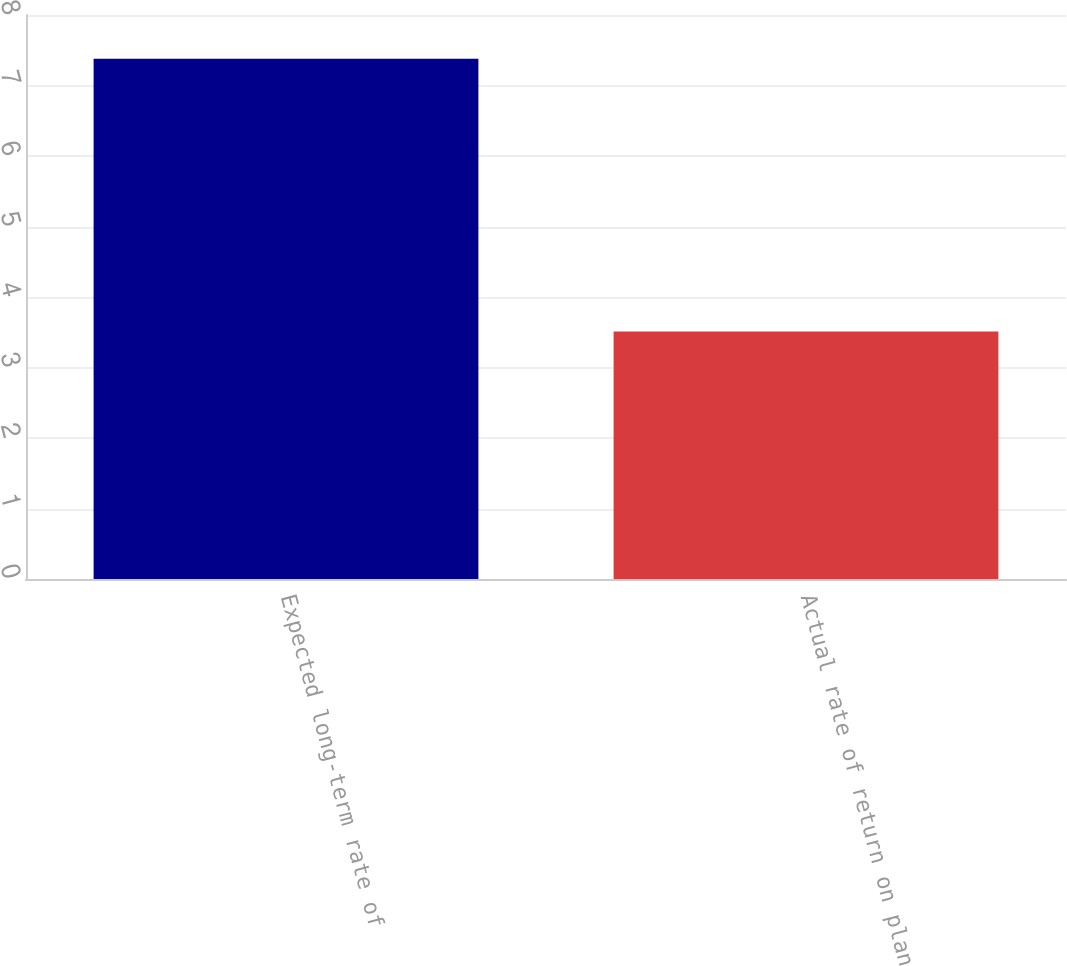<chart> <loc_0><loc_0><loc_500><loc_500><bar_chart><fcel>Expected long-term rate of<fcel>Actual rate of return on plan<nl><fcel>7.38<fcel>3.51<nl></chart> 